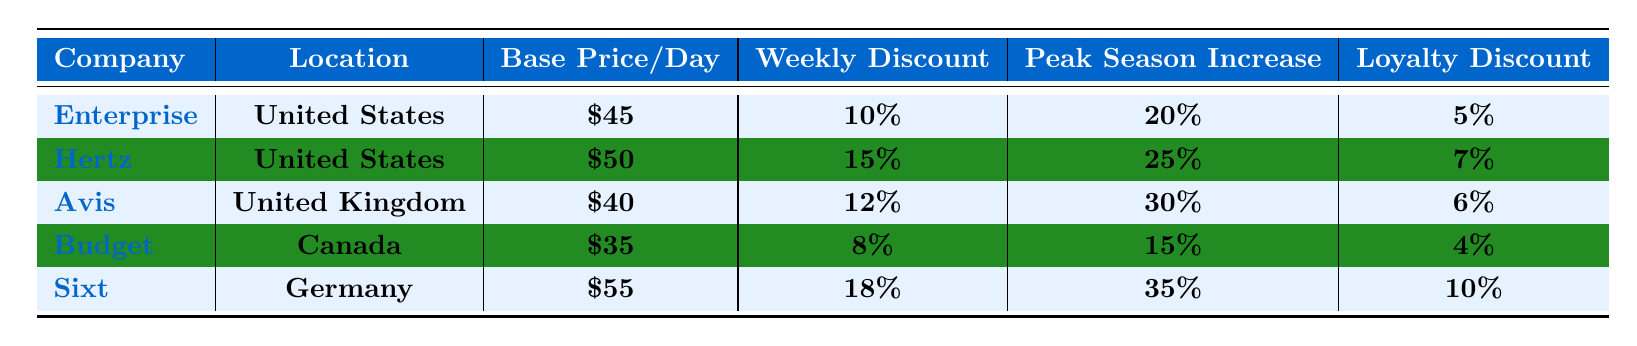What is the base price per day for Hertz? The table lists Hertz's base price per day in the third column, which shows a value of $50.
Answer: $50 Which company offers the highest loyalty program discount? The loyalty program discounts are listed in the last column. Sixt offers the highest discount at 10%.
Answer: Sixt What is the average base price per day for all companies listed? The base prices are $45 (Enterprise), $50 (Hertz), $40 (Avis), $35 (Budget), and $55 (Sixt). Summing these gives $225. Dividing by 5 companies gives an average of $225/5 = $45.
Answer: $45 Is the weekly discount for Budget higher than that for Enterprise? Budget's weekly discount is 8%, while Enterprise's is 10%. Comparing these values shows that Enterprise has a higher weekly discount.
Answer: No What is the difference in percentage between the peak season increase for Sixt and Avis? Sixt has a peak season increase of 35% and Avis has 30%. The difference is 35% - 30% = 5%.
Answer: 5% Which locations have a base price below $45? The table shows that Budget has a base price of $35 and Avis has a base price of $40, both below $45.
Answer: Budget and Avis What is the total discount (base price + loyalty discount) for Avis? Avis has a base price of $40 and a loyalty discount of 6%. Thus, the total discount is $40 + $6 = $46.
Answer: $46 Are the weekly discounts for Hertz and Sixt the same? The weekly discount for Hertz is 15% and for Sixt it is 18%. These values show they are not the same.
Answer: No If a customer rented a vehicle from Enterprise during peak season for a week, what would be the total cost? The base price per day for Enterprise is $45. With a 20% increase during peak season, the new price becomes $45 + ($45 * 0.20) = $54. For a week's rental, this costs $54 * 7 = $378.
Answer: $378 Which company has the lowest base price per day and what is it? The base prices are $45 (Enterprise), $50 (Hertz), $40 (Avis), $35 (Budget), and $55 (Sixt). Budget has the lowest base price at $35.
Answer: Budget with $35 Is there a car rental company that provides a lower off-season price compared to peak season price? The off-season pricing is reflected as a decrease percentage, whereas peak season shows an increase. For Budget, which has a 20% decrease in off-season, the price is significantly reduced compared to peak prices.
Answer: Yes 